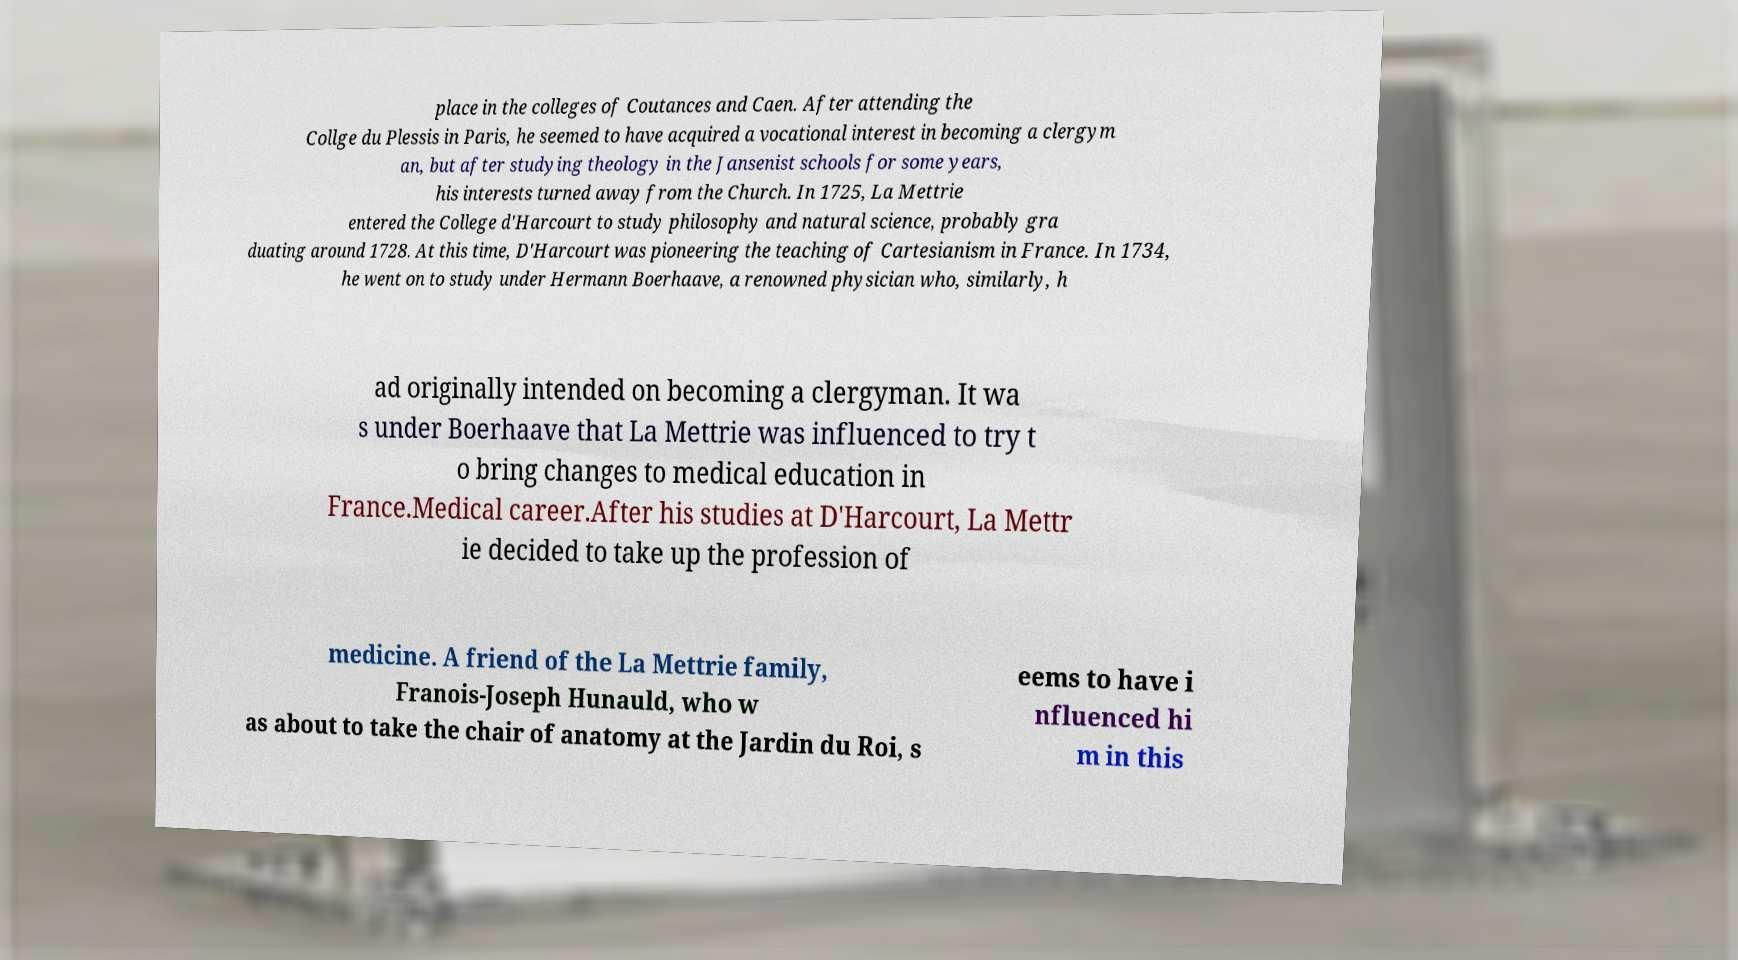Can you read and provide the text displayed in the image?This photo seems to have some interesting text. Can you extract and type it out for me? place in the colleges of Coutances and Caen. After attending the Collge du Plessis in Paris, he seemed to have acquired a vocational interest in becoming a clergym an, but after studying theology in the Jansenist schools for some years, his interests turned away from the Church. In 1725, La Mettrie entered the College d'Harcourt to study philosophy and natural science, probably gra duating around 1728. At this time, D'Harcourt was pioneering the teaching of Cartesianism in France. In 1734, he went on to study under Hermann Boerhaave, a renowned physician who, similarly, h ad originally intended on becoming a clergyman. It wa s under Boerhaave that La Mettrie was influenced to try t o bring changes to medical education in France.Medical career.After his studies at D'Harcourt, La Mettr ie decided to take up the profession of medicine. A friend of the La Mettrie family, Franois-Joseph Hunauld, who w as about to take the chair of anatomy at the Jardin du Roi, s eems to have i nfluenced hi m in this 